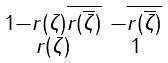Convert formula to latex. <formula><loc_0><loc_0><loc_500><loc_500>\begin{smallmatrix} 1 - r ( \zeta ) \overline { r ( \overline { \zeta } ) } & - \overline { r ( \overline { \zeta } ) } \\ r ( \zeta ) & 1 \end{smallmatrix}</formula> 